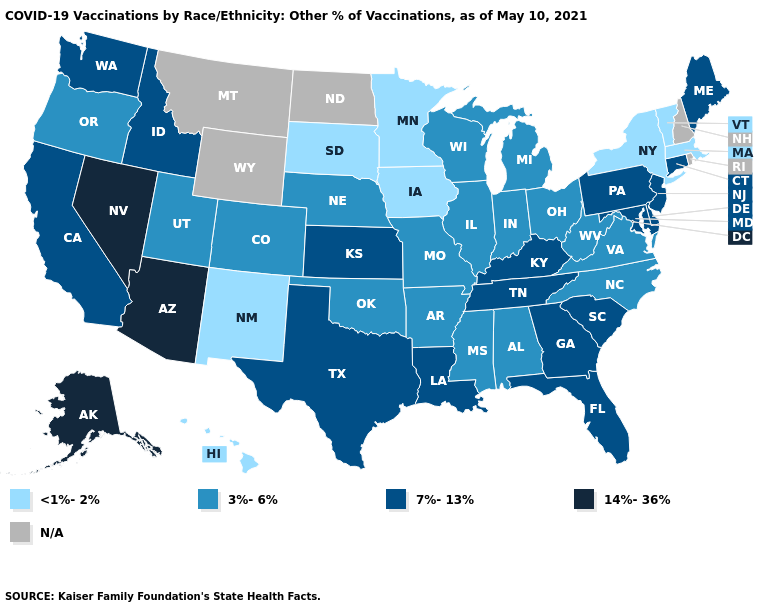Name the states that have a value in the range <1%-2%?
Keep it brief. Hawaii, Iowa, Massachusetts, Minnesota, New Mexico, New York, South Dakota, Vermont. What is the value of Hawaii?
Write a very short answer. <1%-2%. Does Vermont have the lowest value in the USA?
Answer briefly. Yes. What is the value of Maine?
Be succinct. 7%-13%. What is the value of South Carolina?
Concise answer only. 7%-13%. How many symbols are there in the legend?
Keep it brief. 5. Name the states that have a value in the range 3%-6%?
Keep it brief. Alabama, Arkansas, Colorado, Illinois, Indiana, Michigan, Mississippi, Missouri, Nebraska, North Carolina, Ohio, Oklahoma, Oregon, Utah, Virginia, West Virginia, Wisconsin. Does the first symbol in the legend represent the smallest category?
Short answer required. Yes. Among the states that border Alabama , does Tennessee have the lowest value?
Keep it brief. No. What is the value of Louisiana?
Quick response, please. 7%-13%. Name the states that have a value in the range 3%-6%?
Short answer required. Alabama, Arkansas, Colorado, Illinois, Indiana, Michigan, Mississippi, Missouri, Nebraska, North Carolina, Ohio, Oklahoma, Oregon, Utah, Virginia, West Virginia, Wisconsin. Which states have the lowest value in the USA?
Answer briefly. Hawaii, Iowa, Massachusetts, Minnesota, New Mexico, New York, South Dakota, Vermont. What is the highest value in states that border Oklahoma?
Keep it brief. 7%-13%. Name the states that have a value in the range 3%-6%?
Concise answer only. Alabama, Arkansas, Colorado, Illinois, Indiana, Michigan, Mississippi, Missouri, Nebraska, North Carolina, Ohio, Oklahoma, Oregon, Utah, Virginia, West Virginia, Wisconsin. What is the value of Missouri?
Be succinct. 3%-6%. 